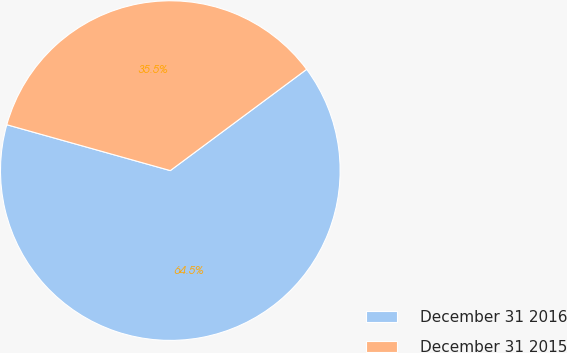Convert chart to OTSL. <chart><loc_0><loc_0><loc_500><loc_500><pie_chart><fcel>December 31 2016<fcel>December 31 2015<nl><fcel>64.52%<fcel>35.48%<nl></chart> 